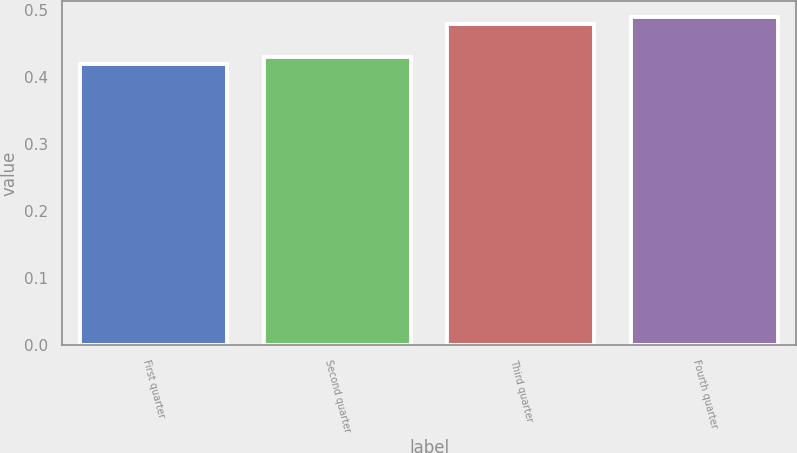Convert chart. <chart><loc_0><loc_0><loc_500><loc_500><bar_chart><fcel>First quarter<fcel>Second quarter<fcel>Third quarter<fcel>Fourth quarter<nl><fcel>0.42<fcel>0.43<fcel>0.48<fcel>0.49<nl></chart> 